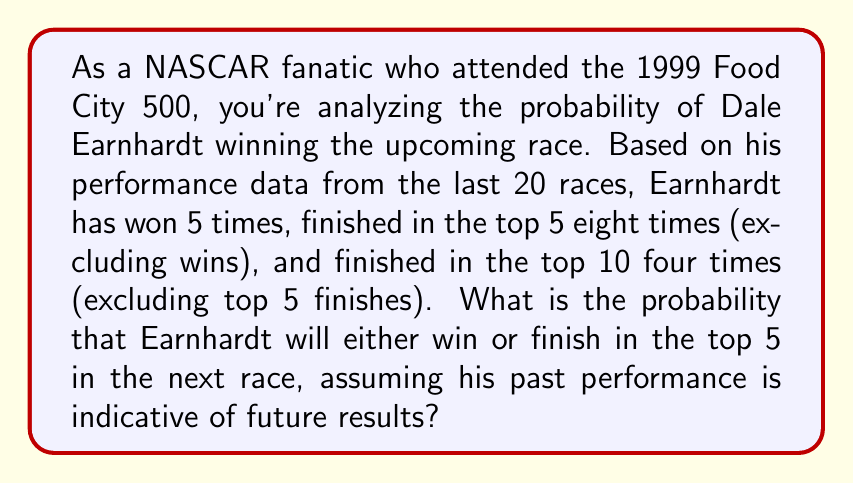Can you answer this question? Let's approach this step-by-step:

1) First, we need to identify the favorable outcomes and the total number of outcomes.

2) Favorable outcomes:
   - Winning the race: 5 times
   - Finishing in the top 5 (excluding wins): 8 times

3) Total number of races: 20

4) To calculate the probability, we use the formula:

   $$P(\text{event}) = \frac{\text{number of favorable outcomes}}{\text{total number of possible outcomes}}$$

5) In this case:
   - Winning: 5 outcomes
   - Top 5 finish (excluding wins): 8 outcomes
   - Total favorable outcomes: 5 + 8 = 13

6) Probability calculation:

   $$P(\text{win or top 5}) = \frac{13}{20}$$

7) To simplify this fraction:

   $$\frac{13}{20} = 0.65$$

Therefore, the probability of Earnhardt either winning or finishing in the top 5 is 0.65 or 65%.
Answer: 0.65 or 65% 